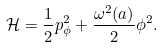<formula> <loc_0><loc_0><loc_500><loc_500>\mathcal { H } = \frac { 1 } { 2 } p _ { \phi } ^ { 2 } + \frac { \omega ^ { 2 } ( a ) } { 2 } \phi ^ { 2 } .</formula> 